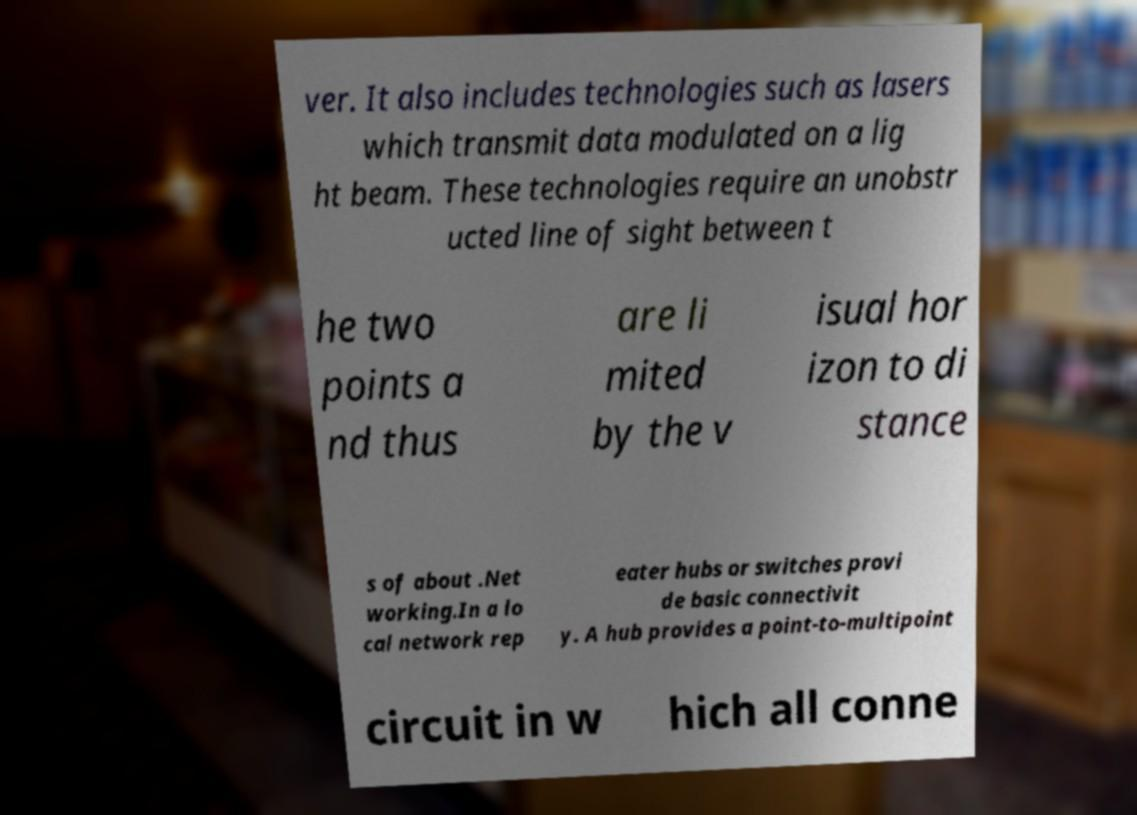What messages or text are displayed in this image? I need them in a readable, typed format. ver. It also includes technologies such as lasers which transmit data modulated on a lig ht beam. These technologies require an unobstr ucted line of sight between t he two points a nd thus are li mited by the v isual hor izon to di stance s of about .Net working.In a lo cal network rep eater hubs or switches provi de basic connectivit y. A hub provides a point-to-multipoint circuit in w hich all conne 